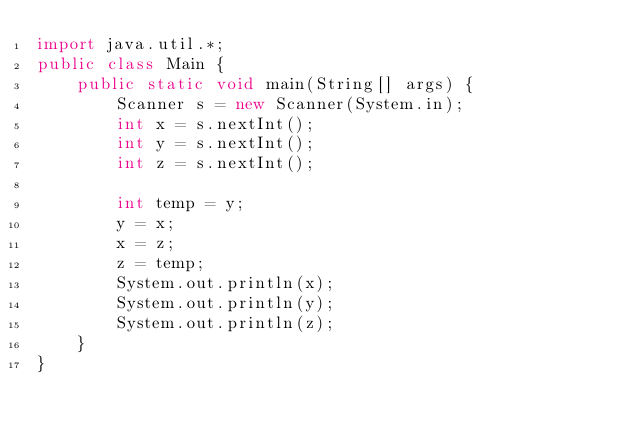Convert code to text. <code><loc_0><loc_0><loc_500><loc_500><_Java_>import java.util.*;
public class Main {
	public static void main(String[] args) {
	    Scanner s = new Scanner(System.in);
	    int x = s.nextInt();
	    int y = s.nextInt();
	    int z = s.nextInt();
	    
	    int temp = y;
	    y = x;
	    x = z;
	    z = temp;
	    System.out.println(x);
	    System.out.println(y);
	    System.out.println(z);
	}
}</code> 